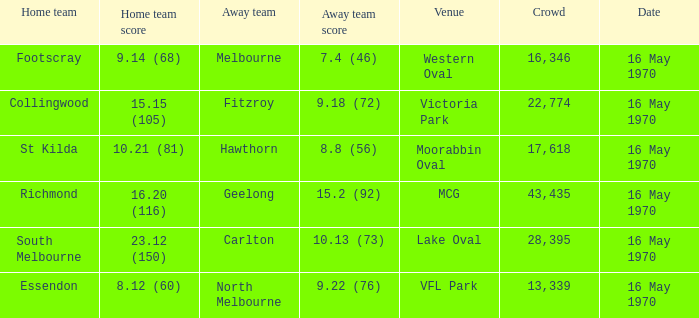Who was the visiting team at western oval? Melbourne. 